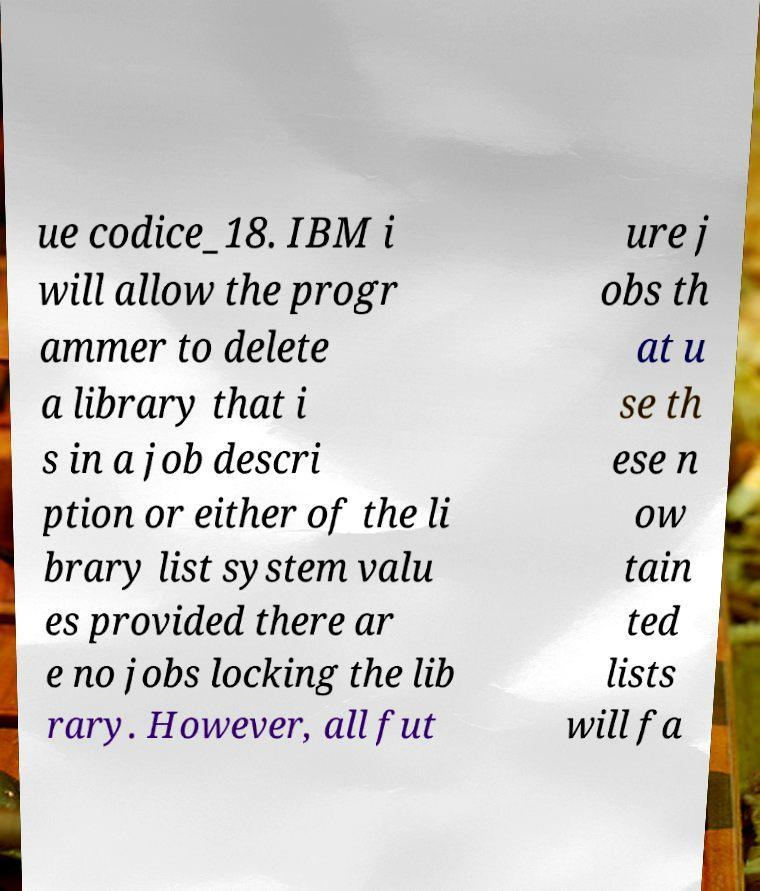Can you accurately transcribe the text from the provided image for me? ue codice_18. IBM i will allow the progr ammer to delete a library that i s in a job descri ption or either of the li brary list system valu es provided there ar e no jobs locking the lib rary. However, all fut ure j obs th at u se th ese n ow tain ted lists will fa 